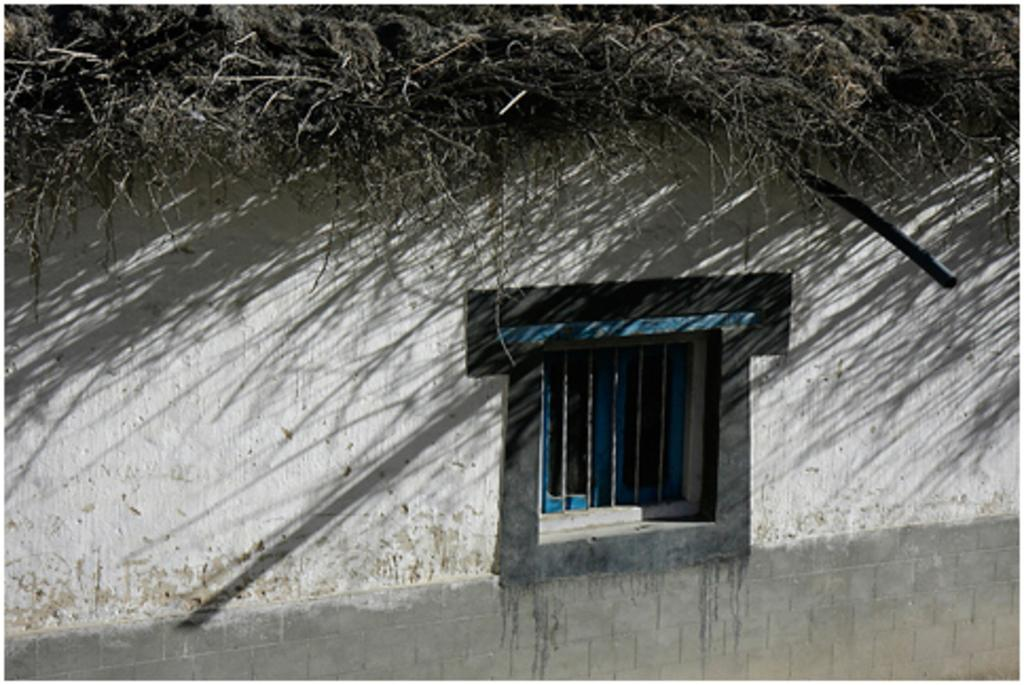What is present on the wall in the image? There is a wall in the image, and there is also a window in the wall. Can you describe the window in the wall? The window is in the wall, but there is no specific information about its size or shape. What type of vegetation can be seen on the wall? There is grass on the wall. What type of flower is growing on top of the wall in the image? There is no flower present on top of the wall in the image. 